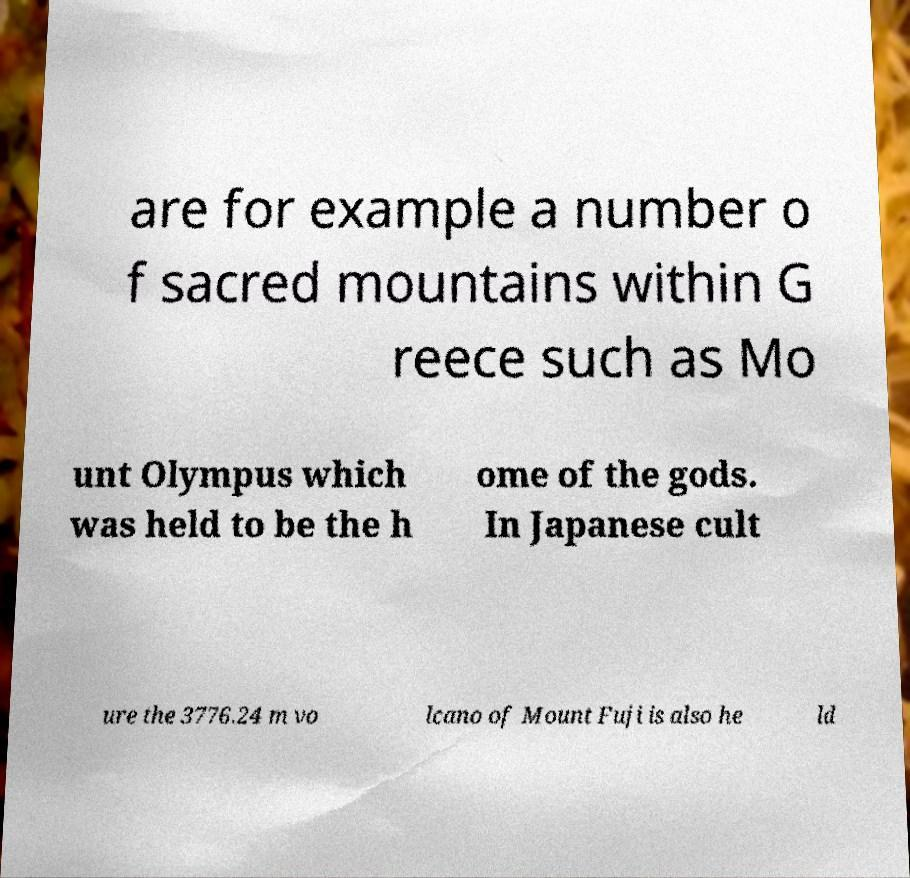Could you extract and type out the text from this image? are for example a number o f sacred mountains within G reece such as Mo unt Olympus which was held to be the h ome of the gods. In Japanese cult ure the 3776.24 m vo lcano of Mount Fuji is also he ld 